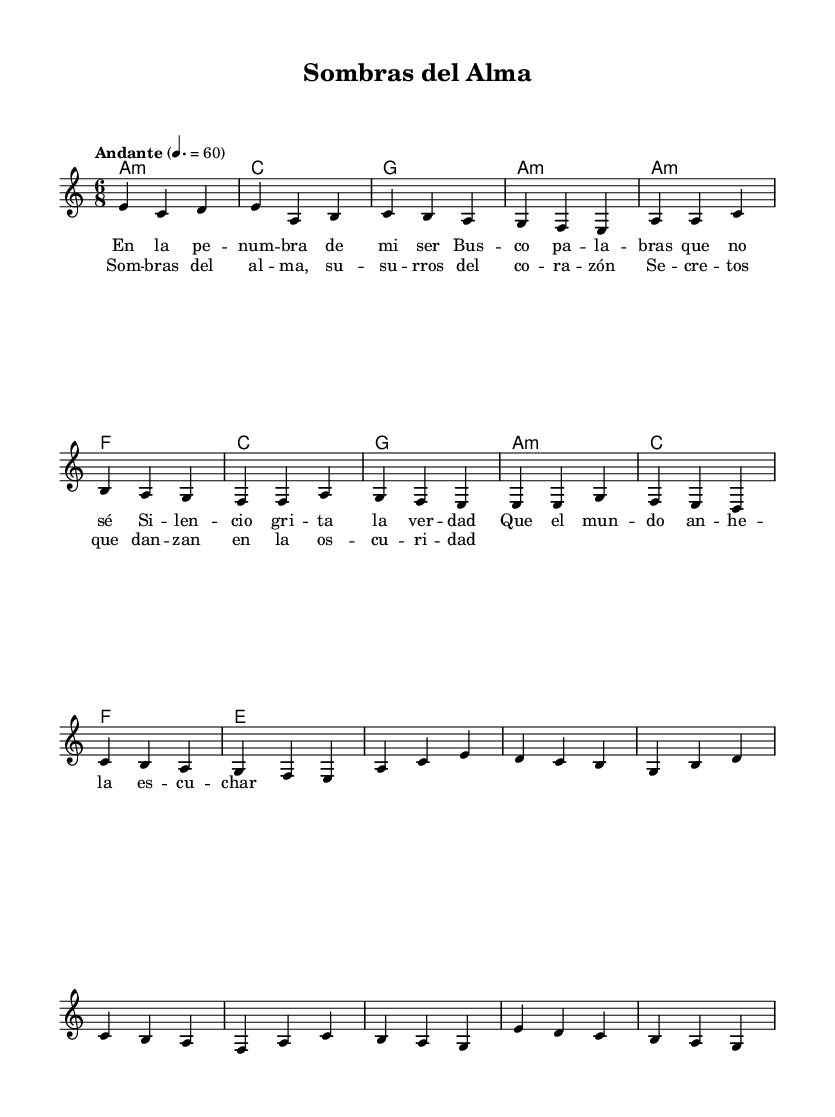What is the key signature of this music? The key signature is indicated at the beginning of the staff. It shows one flat, which is typical for a minor key. In this case, it is A minor.
Answer: A minor What is the time signature of this music? The time signature is displayed at the beginning of the sheet music. It is shown as 6/8, meaning there are six eighth notes per measure.
Answer: 6/8 What is the tempo marking for this piece? The tempo marking is found above the staff and indicates the pace of the music. It says "Andante" with a metronome marking of 60 beats per minute.
Answer: Andante, 60 How many measures are in the verse section? By counting the measures in the verse section from the provided music, there are six measures in total before transitioning to the chorus.
Answer: 6 What type of chord is used in the introduction's first measure? The first measure shows a chord indicated as "a: minor" which denotes it is an A minor chord, as indicated by the symbols in the chord mode section.
Answer: A minor In the chorus, what is the first lyric line? The lyrics section gives the lines of the chorus. The first line explicitly states "Sombras del alma," which means "Shadows of the soul."
Answer: Sombras del alma What is the final note in the melody of the chorus? The melody section indicates the final note in the chorus. Following the notes sequentially, the last note is a G.
Answer: G 